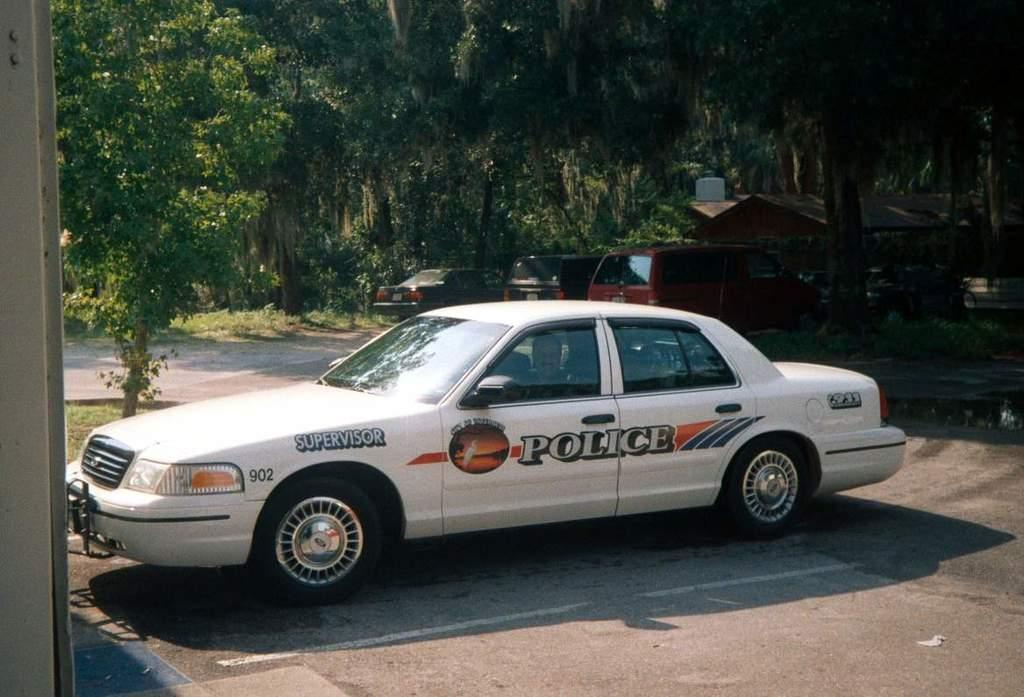What is happening on the road in the image? There are vehicles on the road in the image. What can be seen in the distance behind the vehicles? There are trees and sheds visible in the background of the image. What type of powder is being used to cover the doll in the image? There is no doll or powder present in the image. 